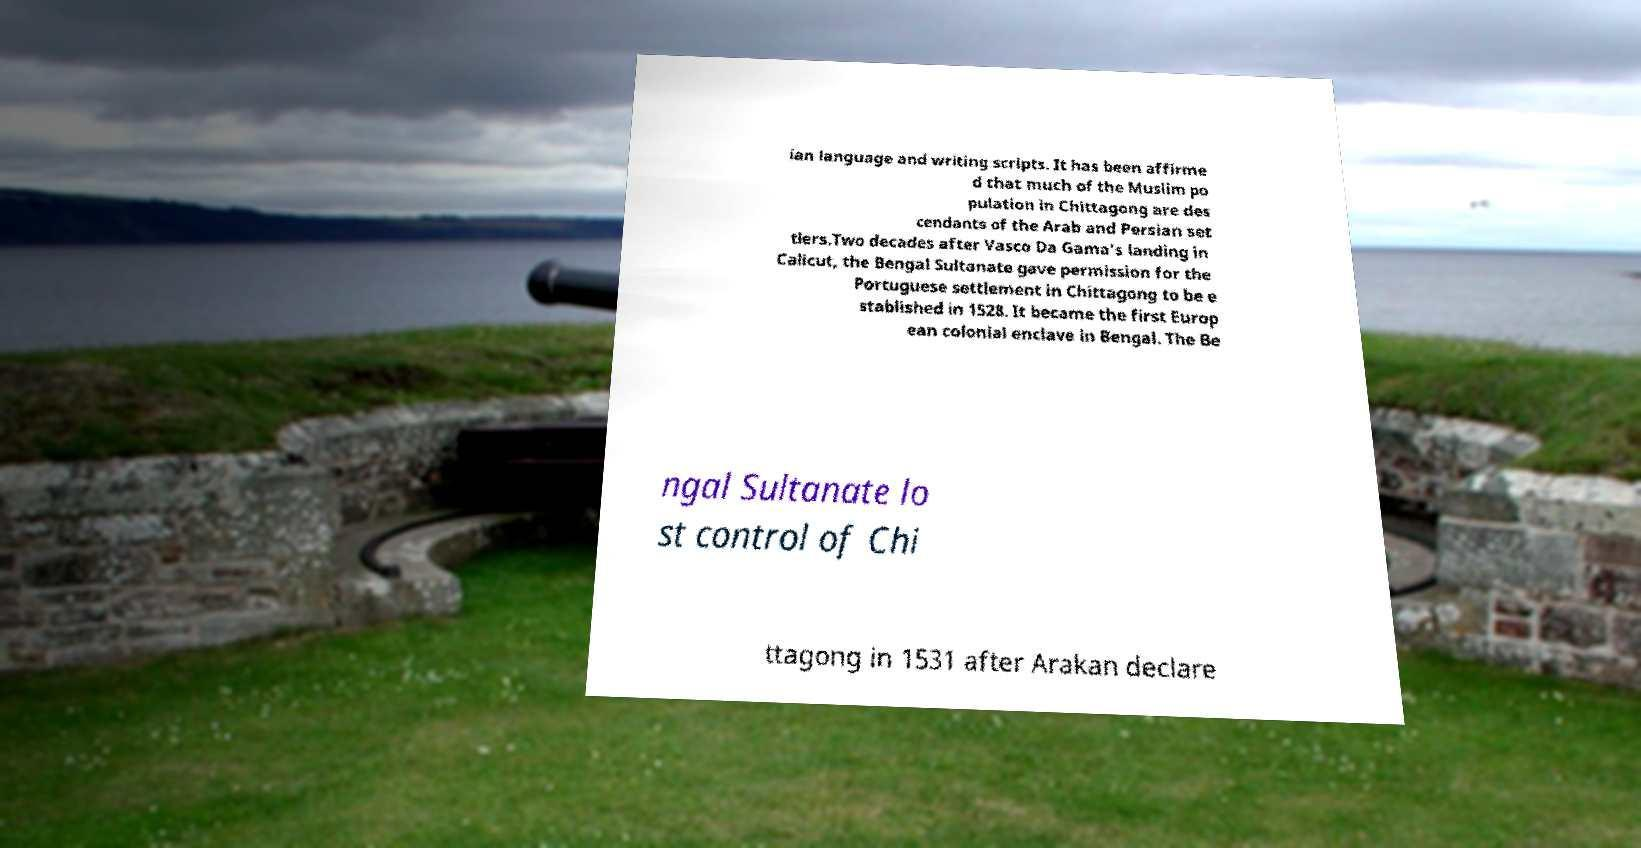Can you read and provide the text displayed in the image?This photo seems to have some interesting text. Can you extract and type it out for me? ian language and writing scripts. It has been affirme d that much of the Muslim po pulation in Chittagong are des cendants of the Arab and Persian set tlers.Two decades after Vasco Da Gama's landing in Calicut, the Bengal Sultanate gave permission for the Portuguese settlement in Chittagong to be e stablished in 1528. It became the first Europ ean colonial enclave in Bengal. The Be ngal Sultanate lo st control of Chi ttagong in 1531 after Arakan declare 